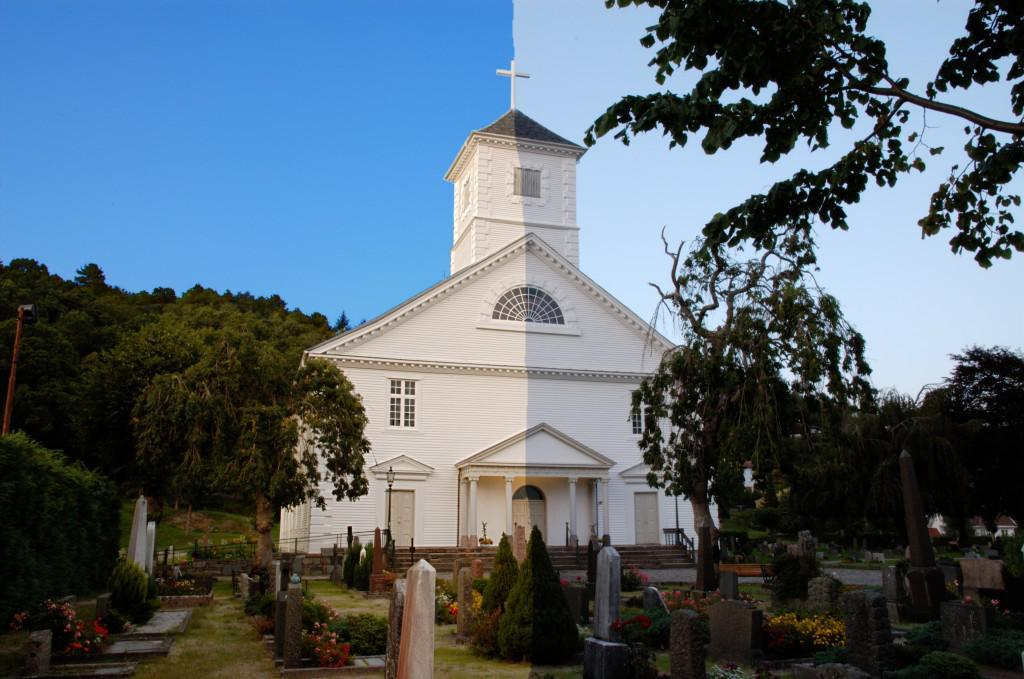What type of building is in the image? There is a church building in the image. What is located in front of the church building? There are headstones in front of the church building. What can be seen around the church building? There are trees around the church building. What is placed in front of the headstones? There are flower bouquets in front of the headstones. What color is the chalk used to draw on the nail in the image? There is no chalk or nail present in the image. 